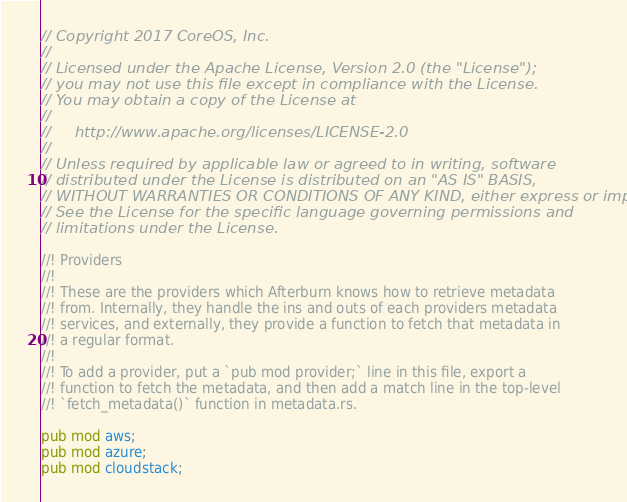<code> <loc_0><loc_0><loc_500><loc_500><_Rust_>// Copyright 2017 CoreOS, Inc.
//
// Licensed under the Apache License, Version 2.0 (the "License");
// you may not use this file except in compliance with the License.
// You may obtain a copy of the License at
//
//     http://www.apache.org/licenses/LICENSE-2.0
//
// Unless required by applicable law or agreed to in writing, software
// distributed under the License is distributed on an "AS IS" BASIS,
// WITHOUT WARRANTIES OR CONDITIONS OF ANY KIND, either express or implied.
// See the License for the specific language governing permissions and
// limitations under the License.

//! Providers
//!
//! These are the providers which Afterburn knows how to retrieve metadata
//! from. Internally, they handle the ins and outs of each providers metadata
//! services, and externally, they provide a function to fetch that metadata in
//! a regular format.
//!
//! To add a provider, put a `pub mod provider;` line in this file, export a
//! function to fetch the metadata, and then add a match line in the top-level
//! `fetch_metadata()` function in metadata.rs.

pub mod aws;
pub mod azure;
pub mod cloudstack;</code> 